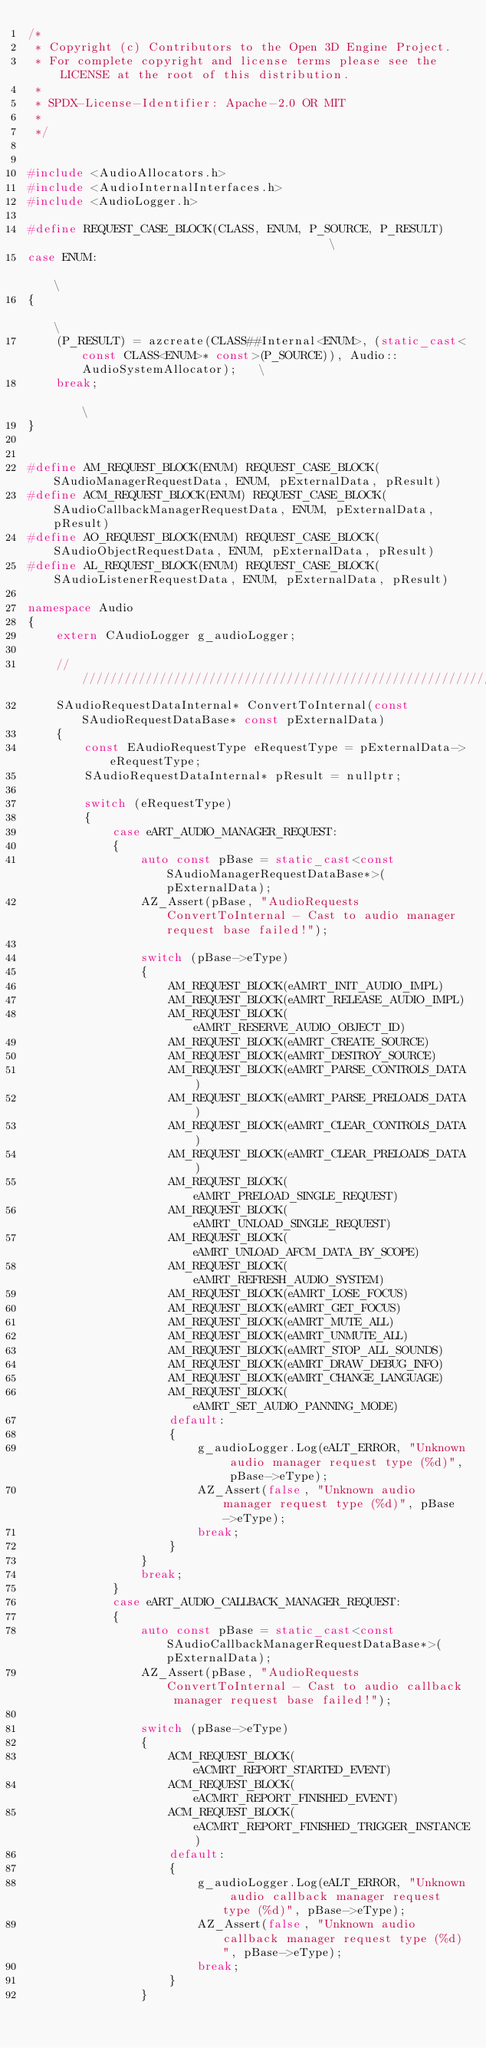Convert code to text. <code><loc_0><loc_0><loc_500><loc_500><_C++_>/*
 * Copyright (c) Contributors to the Open 3D Engine Project.
 * For complete copyright and license terms please see the LICENSE at the root of this distribution.
 *
 * SPDX-License-Identifier: Apache-2.0 OR MIT
 *
 */


#include <AudioAllocators.h>
#include <AudioInternalInterfaces.h>
#include <AudioLogger.h>

#define REQUEST_CASE_BLOCK(CLASS, ENUM, P_SOURCE, P_RESULT)                                        \
case ENUM:                                                                                         \
{                                                                                                  \
    (P_RESULT) = azcreate(CLASS##Internal<ENUM>, (static_cast<const CLASS<ENUM>* const>(P_SOURCE)), Audio::AudioSystemAllocator);   \
    break;                                                                                         \
}


#define AM_REQUEST_BLOCK(ENUM) REQUEST_CASE_BLOCK(SAudioManagerRequestData, ENUM, pExternalData, pResult)
#define ACM_REQUEST_BLOCK(ENUM) REQUEST_CASE_BLOCK(SAudioCallbackManagerRequestData, ENUM, pExternalData, pResult)
#define AO_REQUEST_BLOCK(ENUM) REQUEST_CASE_BLOCK(SAudioObjectRequestData, ENUM, pExternalData, pResult)
#define AL_REQUEST_BLOCK(ENUM) REQUEST_CASE_BLOCK(SAudioListenerRequestData, ENUM, pExternalData, pResult)

namespace Audio
{
    extern CAudioLogger g_audioLogger;

    ///////////////////////////////////////////////////////////////////////////////////////////////////
    SAudioRequestDataInternal* ConvertToInternal(const SAudioRequestDataBase* const pExternalData)
    {
        const EAudioRequestType eRequestType = pExternalData->eRequestType;
        SAudioRequestDataInternal* pResult = nullptr;

        switch (eRequestType)
        {
            case eART_AUDIO_MANAGER_REQUEST:
            {
                auto const pBase = static_cast<const SAudioManagerRequestDataBase*>(pExternalData);
                AZ_Assert(pBase, "AudioRequests ConvertToInternal - Cast to audio manager request base failed!");

                switch (pBase->eType)
                {
                    AM_REQUEST_BLOCK(eAMRT_INIT_AUDIO_IMPL)
                    AM_REQUEST_BLOCK(eAMRT_RELEASE_AUDIO_IMPL)
                    AM_REQUEST_BLOCK(eAMRT_RESERVE_AUDIO_OBJECT_ID)
                    AM_REQUEST_BLOCK(eAMRT_CREATE_SOURCE)
                    AM_REQUEST_BLOCK(eAMRT_DESTROY_SOURCE)
                    AM_REQUEST_BLOCK(eAMRT_PARSE_CONTROLS_DATA)
                    AM_REQUEST_BLOCK(eAMRT_PARSE_PRELOADS_DATA)
                    AM_REQUEST_BLOCK(eAMRT_CLEAR_CONTROLS_DATA)
                    AM_REQUEST_BLOCK(eAMRT_CLEAR_PRELOADS_DATA)
                    AM_REQUEST_BLOCK(eAMRT_PRELOAD_SINGLE_REQUEST)
                    AM_REQUEST_BLOCK(eAMRT_UNLOAD_SINGLE_REQUEST)
                    AM_REQUEST_BLOCK(eAMRT_UNLOAD_AFCM_DATA_BY_SCOPE)
                    AM_REQUEST_BLOCK(eAMRT_REFRESH_AUDIO_SYSTEM)
                    AM_REQUEST_BLOCK(eAMRT_LOSE_FOCUS)
                    AM_REQUEST_BLOCK(eAMRT_GET_FOCUS)
                    AM_REQUEST_BLOCK(eAMRT_MUTE_ALL)
                    AM_REQUEST_BLOCK(eAMRT_UNMUTE_ALL)
                    AM_REQUEST_BLOCK(eAMRT_STOP_ALL_SOUNDS)
                    AM_REQUEST_BLOCK(eAMRT_DRAW_DEBUG_INFO)
                    AM_REQUEST_BLOCK(eAMRT_CHANGE_LANGUAGE)
                    AM_REQUEST_BLOCK(eAMRT_SET_AUDIO_PANNING_MODE)
                    default:
                    {
                        g_audioLogger.Log(eALT_ERROR, "Unknown audio manager request type (%d)", pBase->eType);
                        AZ_Assert(false, "Unknown audio manager request type (%d)", pBase->eType);
                        break;
                    }
                }
                break;
            }
            case eART_AUDIO_CALLBACK_MANAGER_REQUEST:
            {
                auto const pBase = static_cast<const SAudioCallbackManagerRequestDataBase*>(pExternalData);
                AZ_Assert(pBase, "AudioRequests ConvertToInternal - Cast to audio callback manager request base failed!");

                switch (pBase->eType)
                {
                    ACM_REQUEST_BLOCK(eACMRT_REPORT_STARTED_EVENT)
                    ACM_REQUEST_BLOCK(eACMRT_REPORT_FINISHED_EVENT)
                    ACM_REQUEST_BLOCK(eACMRT_REPORT_FINISHED_TRIGGER_INSTANCE)
                    default:
                    {
                        g_audioLogger.Log(eALT_ERROR, "Unknown audio callback manager request type (%d)", pBase->eType);
                        AZ_Assert(false, "Unknown audio callback manager request type (%d)", pBase->eType);
                        break;
                    }
                }</code> 